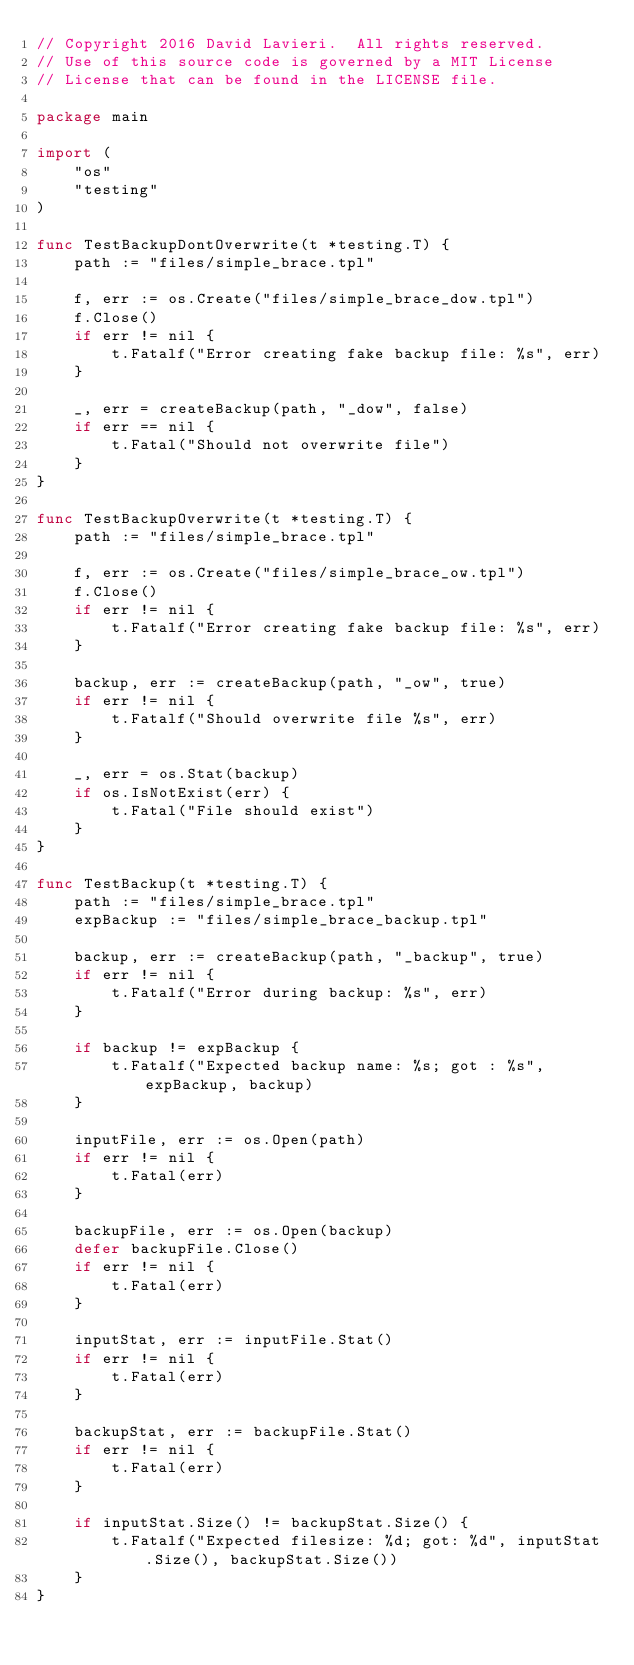Convert code to text. <code><loc_0><loc_0><loc_500><loc_500><_Go_>// Copyright 2016 David Lavieri.  All rights reserved.
// Use of this source code is governed by a MIT License
// License that can be found in the LICENSE file.

package main

import (
	"os"
	"testing"
)

func TestBackupDontOverwrite(t *testing.T) {
	path := "files/simple_brace.tpl"

	f, err := os.Create("files/simple_brace_dow.tpl")
	f.Close()
	if err != nil {
		t.Fatalf("Error creating fake backup file: %s", err)
	}

	_, err = createBackup(path, "_dow", false)
	if err == nil {
		t.Fatal("Should not overwrite file")
	}
}

func TestBackupOverwrite(t *testing.T) {
	path := "files/simple_brace.tpl"

	f, err := os.Create("files/simple_brace_ow.tpl")
	f.Close()
	if err != nil {
		t.Fatalf("Error creating fake backup file: %s", err)
	}

	backup, err := createBackup(path, "_ow", true)
	if err != nil {
		t.Fatalf("Should overwrite file %s", err)
	}

	_, err = os.Stat(backup)
	if os.IsNotExist(err) {
		t.Fatal("File should exist")
	}
}

func TestBackup(t *testing.T) {
	path := "files/simple_brace.tpl"
	expBackup := "files/simple_brace_backup.tpl"

	backup, err := createBackup(path, "_backup", true)
	if err != nil {
		t.Fatalf("Error during backup: %s", err)
	}

	if backup != expBackup {
		t.Fatalf("Expected backup name: %s; got : %s", expBackup, backup)
	}

	inputFile, err := os.Open(path)
	if err != nil {
		t.Fatal(err)
	}

	backupFile, err := os.Open(backup)
	defer backupFile.Close()
	if err != nil {
		t.Fatal(err)
	}

	inputStat, err := inputFile.Stat()
	if err != nil {
		t.Fatal(err)
	}

	backupStat, err := backupFile.Stat()
	if err != nil {
		t.Fatal(err)
	}

	if inputStat.Size() != backupStat.Size() {
		t.Fatalf("Expected filesize: %d; got: %d", inputStat.Size(), backupStat.Size())
	}
}
</code> 